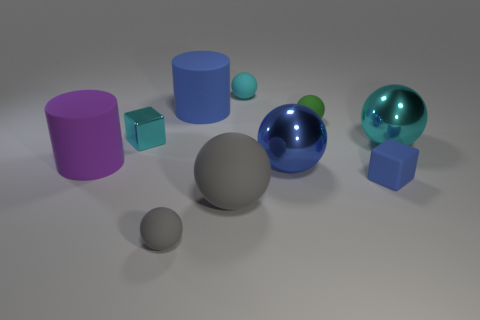How many things are blue blocks or small cyan balls?
Your answer should be very brief. 2. How many large objects are either blue matte balls or matte cylinders?
Give a very brief answer. 2. Is there any other thing that is the same color as the metallic cube?
Your answer should be compact. Yes. What is the size of the sphere that is both to the right of the big blue sphere and to the left of the large cyan thing?
Provide a short and direct response. Small. Is the color of the big rubber cylinder in front of the tiny green sphere the same as the cube behind the large blue metallic object?
Make the answer very short. No. How many other things are the same material as the small cyan cube?
Offer a very short reply. 2. What is the shape of the metal object that is right of the cyan block and left of the small blue matte block?
Keep it short and to the point. Sphere. There is a metallic cube; is it the same color as the cylinder on the right side of the tiny metallic cube?
Provide a short and direct response. No. There is a cylinder that is to the left of the metallic cube; is its size the same as the tiny cyan cube?
Offer a very short reply. No. There is a big cyan object that is the same shape as the small gray thing; what material is it?
Make the answer very short. Metal. 